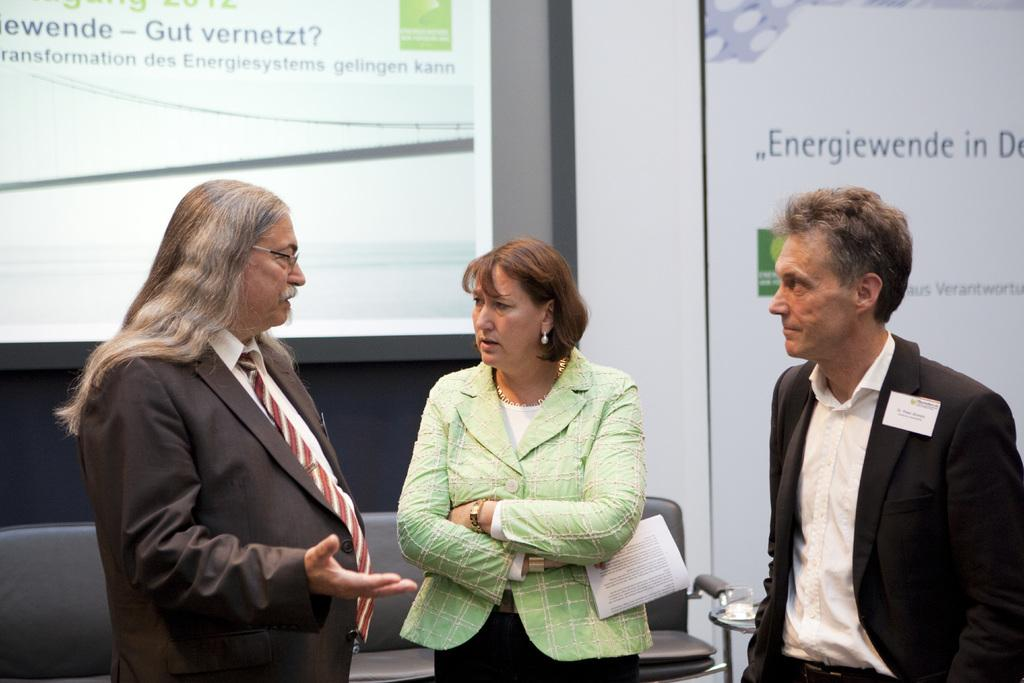How many people are present in the image? There are three persons in the image. What type of furniture is visible in the image? There is a sofa in the image. What can be seen in the background of the image? There is a projector screen in the background of the image. What type of wine is being served on the sofa in the image? There is no wine present in the image; it only features three persons and a sofa. 